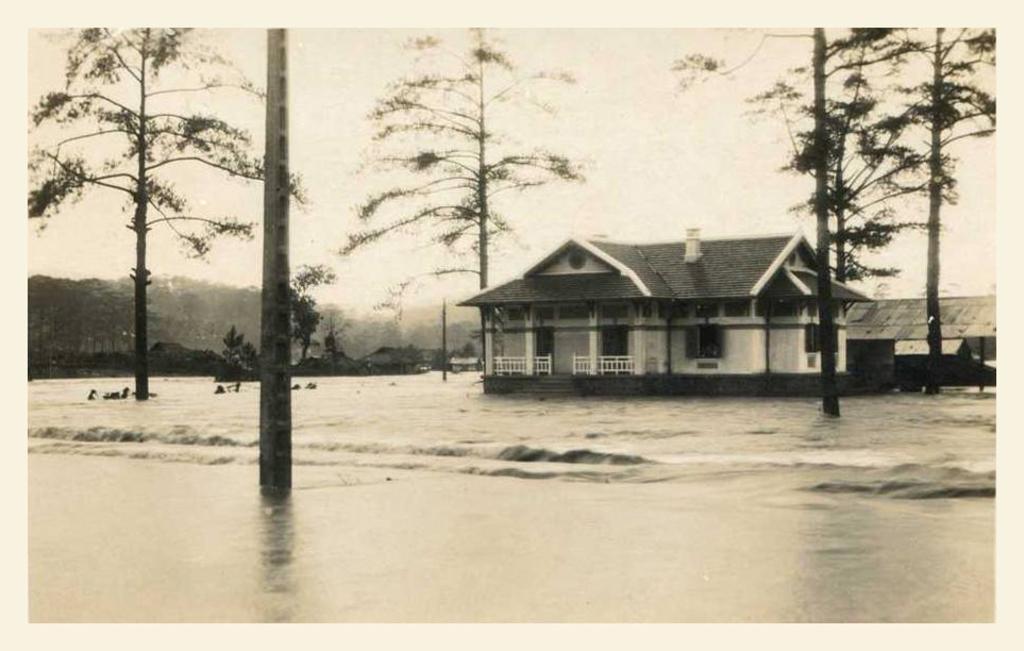Can you describe this image briefly? In this image there is water. There are trees. There are houses. There is a sky. 